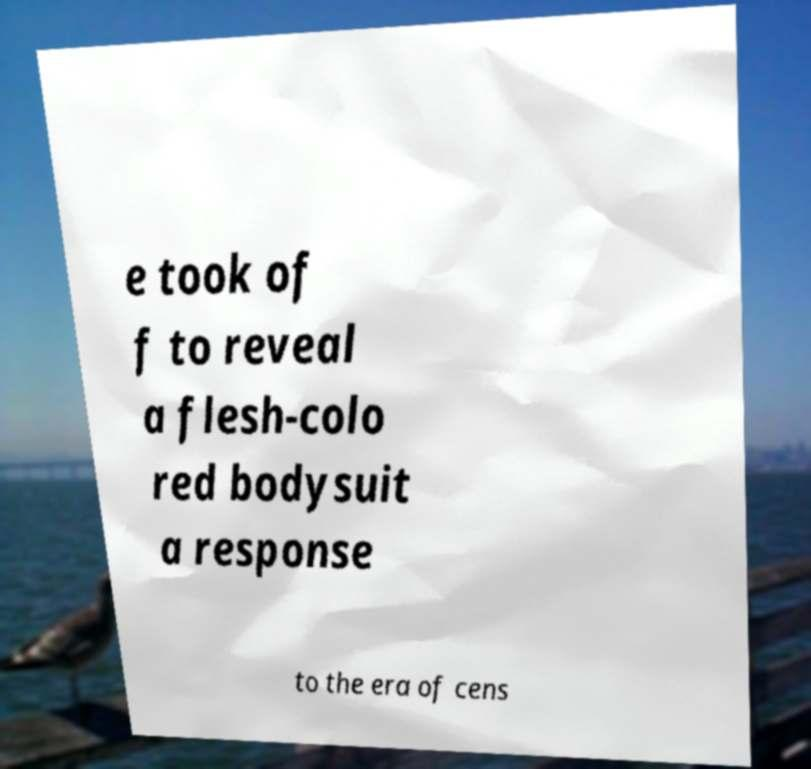What messages or text are displayed in this image? I need them in a readable, typed format. e took of f to reveal a flesh-colo red bodysuit a response to the era of cens 